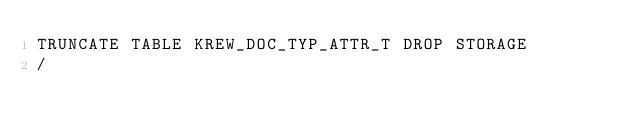<code> <loc_0><loc_0><loc_500><loc_500><_SQL_>TRUNCATE TABLE KREW_DOC_TYP_ATTR_T DROP STORAGE
/</code> 